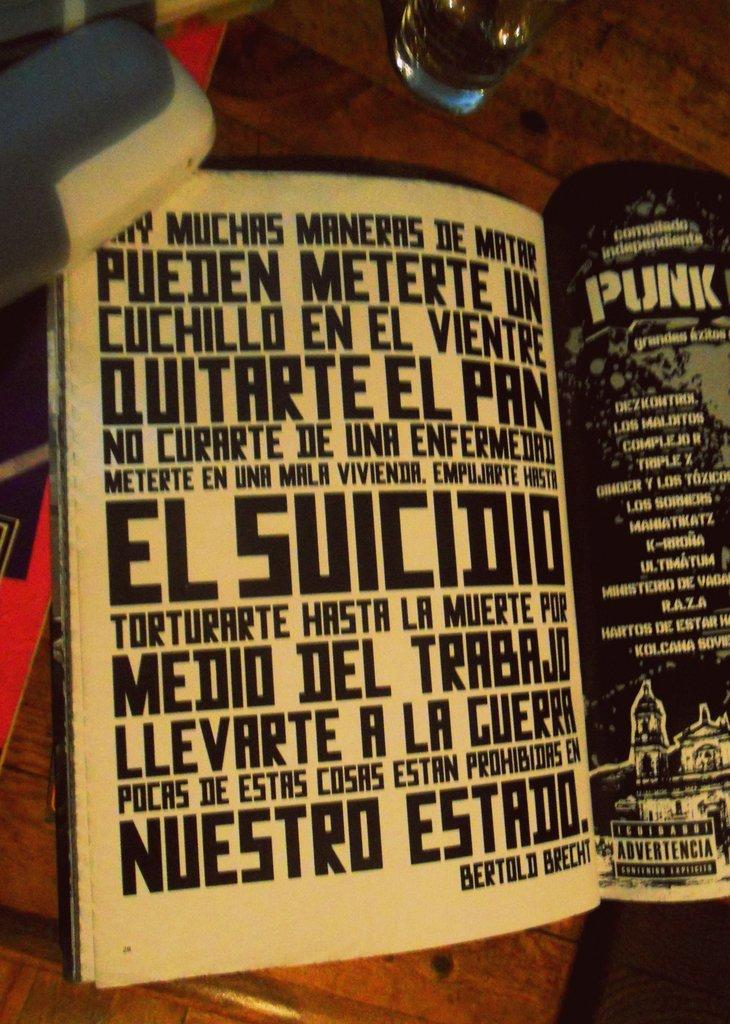<image>
Write a terse but informative summary of the picture. A quote in spanish about the many ways to die is advertised in a book. 